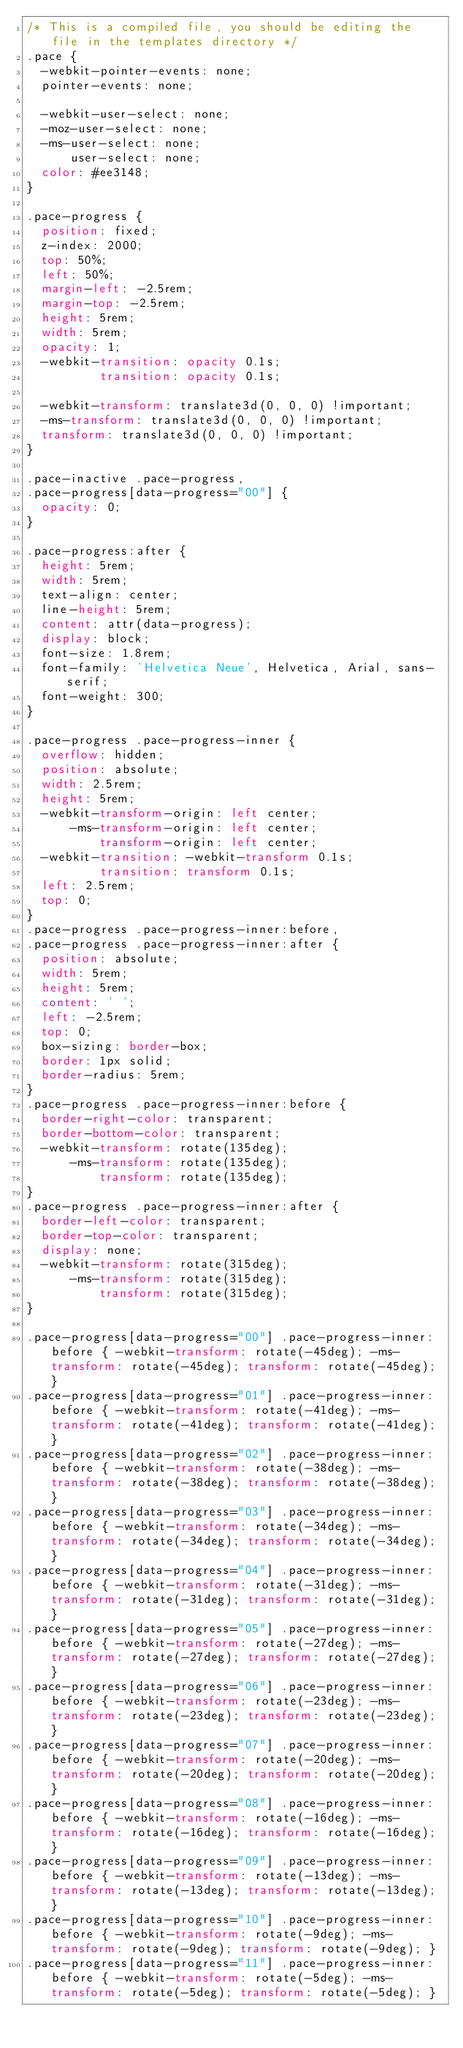<code> <loc_0><loc_0><loc_500><loc_500><_CSS_>/* This is a compiled file, you should be editing the file in the templates directory */
.pace {
  -webkit-pointer-events: none;
  pointer-events: none;

  -webkit-user-select: none;
  -moz-user-select: none;
  -ms-user-select: none;
      user-select: none;
  color: #ee3148;
}

.pace-progress {
  position: fixed;
  z-index: 2000;
  top: 50%;
  left: 50%;
  margin-left: -2.5rem;
  margin-top: -2.5rem;
  height: 5rem;
  width: 5rem;
  opacity: 1;
  -webkit-transition: opacity 0.1s;
          transition: opacity 0.1s;

  -webkit-transform: translate3d(0, 0, 0) !important;
  -ms-transform: translate3d(0, 0, 0) !important;
  transform: translate3d(0, 0, 0) !important;
}

.pace-inactive .pace-progress,
.pace-progress[data-progress="00"] {
  opacity: 0;
}

.pace-progress:after {
  height: 5rem;
  width: 5rem;
  text-align: center;
  line-height: 5rem;
  content: attr(data-progress);
  display: block;
  font-size: 1.8rem;
  font-family: 'Helvetica Neue', Helvetica, Arial, sans-serif;
  font-weight: 300;
}

.pace-progress .pace-progress-inner {
  overflow: hidden;
  position: absolute;
  width: 2.5rem;
  height: 5rem;
  -webkit-transform-origin: left center;
      -ms-transform-origin: left center;
          transform-origin: left center;
  -webkit-transition: -webkit-transform 0.1s;
          transition: transform 0.1s;
  left: 2.5rem;
  top: 0;
}
.pace-progress .pace-progress-inner:before,
.pace-progress .pace-progress-inner:after {
  position: absolute;
  width: 5rem;
  height: 5rem;
  content: ' ';
  left: -2.5rem;
  top: 0;
  box-sizing: border-box;
  border: 1px solid;
  border-radius: 5rem;
}
.pace-progress .pace-progress-inner:before {
  border-right-color: transparent;
  border-bottom-color: transparent;
  -webkit-transform: rotate(135deg);
      -ms-transform: rotate(135deg);
          transform: rotate(135deg);
}
.pace-progress .pace-progress-inner:after {
  border-left-color: transparent;
  border-top-color: transparent;
  display: none;
  -webkit-transform: rotate(315deg);
      -ms-transform: rotate(315deg);
          transform: rotate(315deg);
}

.pace-progress[data-progress="00"] .pace-progress-inner:before { -webkit-transform: rotate(-45deg); -ms-transform: rotate(-45deg); transform: rotate(-45deg); }
.pace-progress[data-progress="01"] .pace-progress-inner:before { -webkit-transform: rotate(-41deg); -ms-transform: rotate(-41deg); transform: rotate(-41deg); }
.pace-progress[data-progress="02"] .pace-progress-inner:before { -webkit-transform: rotate(-38deg); -ms-transform: rotate(-38deg); transform: rotate(-38deg); }
.pace-progress[data-progress="03"] .pace-progress-inner:before { -webkit-transform: rotate(-34deg); -ms-transform: rotate(-34deg); transform: rotate(-34deg); }
.pace-progress[data-progress="04"] .pace-progress-inner:before { -webkit-transform: rotate(-31deg); -ms-transform: rotate(-31deg); transform: rotate(-31deg); }
.pace-progress[data-progress="05"] .pace-progress-inner:before { -webkit-transform: rotate(-27deg); -ms-transform: rotate(-27deg); transform: rotate(-27deg); }
.pace-progress[data-progress="06"] .pace-progress-inner:before { -webkit-transform: rotate(-23deg); -ms-transform: rotate(-23deg); transform: rotate(-23deg); }
.pace-progress[data-progress="07"] .pace-progress-inner:before { -webkit-transform: rotate(-20deg); -ms-transform: rotate(-20deg); transform: rotate(-20deg); }
.pace-progress[data-progress="08"] .pace-progress-inner:before { -webkit-transform: rotate(-16deg); -ms-transform: rotate(-16deg); transform: rotate(-16deg); }
.pace-progress[data-progress="09"] .pace-progress-inner:before { -webkit-transform: rotate(-13deg); -ms-transform: rotate(-13deg); transform: rotate(-13deg); }
.pace-progress[data-progress="10"] .pace-progress-inner:before { -webkit-transform: rotate(-9deg); -ms-transform: rotate(-9deg); transform: rotate(-9deg); }
.pace-progress[data-progress="11"] .pace-progress-inner:before { -webkit-transform: rotate(-5deg); -ms-transform: rotate(-5deg); transform: rotate(-5deg); }</code> 